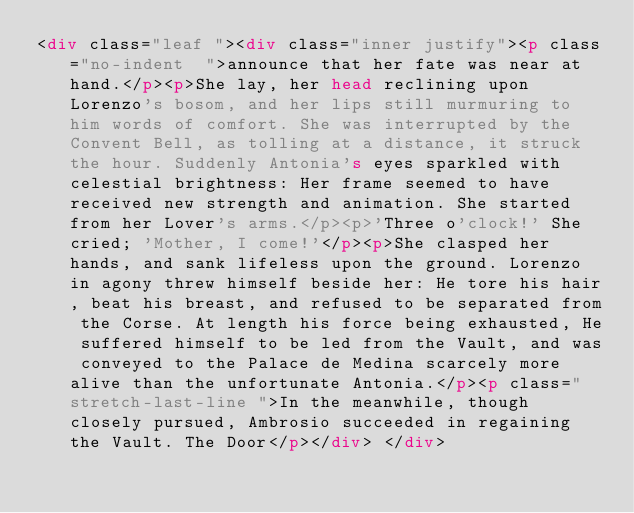<code> <loc_0><loc_0><loc_500><loc_500><_HTML_><div class="leaf "><div class="inner justify"><p class="no-indent  ">announce that her fate was near at hand.</p><p>She lay, her head reclining upon Lorenzo's bosom, and her lips still murmuring to him words of comfort. She was interrupted by the Convent Bell, as tolling at a distance, it struck the hour. Suddenly Antonia's eyes sparkled with celestial brightness: Her frame seemed to have received new strength and animation. She started from her Lover's arms.</p><p>'Three o'clock!' She cried; 'Mother, I come!'</p><p>She clasped her hands, and sank lifeless upon the ground. Lorenzo in agony threw himself beside her: He tore his hair, beat his breast, and refused to be separated from the Corse. At length his force being exhausted, He suffered himself to be led from the Vault, and was conveyed to the Palace de Medina scarcely more alive than the unfortunate Antonia.</p><p class=" stretch-last-line ">In the meanwhile, though closely pursued, Ambrosio succeeded in regaining the Vault. The Door</p></div> </div></code> 